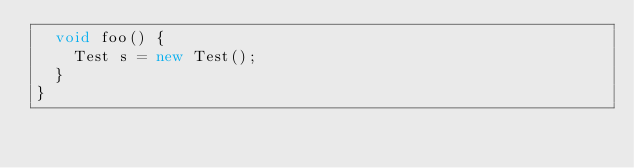<code> <loc_0><loc_0><loc_500><loc_500><_Java_>  void foo() {
    Test s = new Test();
  }
}</code> 